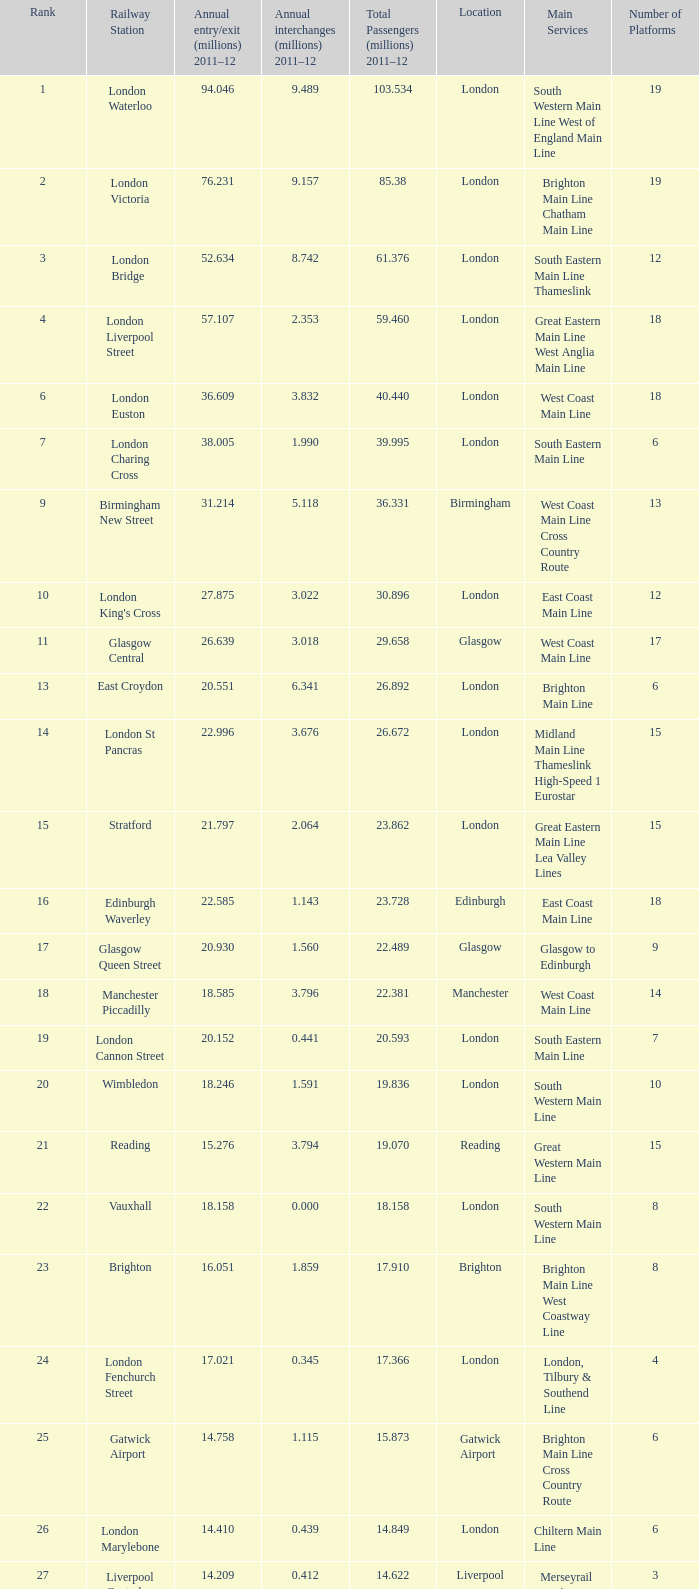Could you help me parse every detail presented in this table? {'header': ['Rank', 'Railway Station', 'Annual entry/exit (millions) 2011–12', 'Annual interchanges (millions) 2011–12', 'Total Passengers (millions) 2011–12', 'Location', 'Main Services', 'Number of Platforms'], 'rows': [['1', 'London Waterloo', '94.046', '9.489', '103.534', 'London', 'South Western Main Line West of England Main Line', '19'], ['2', 'London Victoria', '76.231', '9.157', '85.38', 'London', 'Brighton Main Line Chatham Main Line', '19'], ['3', 'London Bridge', '52.634', '8.742', '61.376', 'London', 'South Eastern Main Line Thameslink', '12'], ['4', 'London Liverpool Street', '57.107', '2.353', '59.460', 'London', 'Great Eastern Main Line West Anglia Main Line', '18'], ['6', 'London Euston', '36.609', '3.832', '40.440', 'London', 'West Coast Main Line', '18'], ['7', 'London Charing Cross', '38.005', '1.990', '39.995', 'London', 'South Eastern Main Line', '6'], ['9', 'Birmingham New Street', '31.214', '5.118', '36.331', 'Birmingham', 'West Coast Main Line Cross Country Route', '13'], ['10', "London King's Cross", '27.875', '3.022', '30.896', 'London', 'East Coast Main Line', '12'], ['11', 'Glasgow Central', '26.639', '3.018', '29.658', 'Glasgow', 'West Coast Main Line', '17'], ['13', 'East Croydon', '20.551', '6.341', '26.892', 'London', 'Brighton Main Line', '6'], ['14', 'London St Pancras', '22.996', '3.676', '26.672', 'London', 'Midland Main Line Thameslink High-Speed 1 Eurostar', '15'], ['15', 'Stratford', '21.797', '2.064', '23.862', 'London', 'Great Eastern Main Line Lea Valley Lines', '15'], ['16', 'Edinburgh Waverley', '22.585', '1.143', '23.728', 'Edinburgh', 'East Coast Main Line', '18'], ['17', 'Glasgow Queen Street', '20.930', '1.560', '22.489', 'Glasgow', 'Glasgow to Edinburgh', '9'], ['18', 'Manchester Piccadilly', '18.585', '3.796', '22.381', 'Manchester', 'West Coast Main Line', '14'], ['19', 'London Cannon Street', '20.152', '0.441', '20.593', 'London', 'South Eastern Main Line', '7'], ['20', 'Wimbledon', '18.246', '1.591', '19.836', 'London', 'South Western Main Line', '10'], ['21', 'Reading', '15.276', '3.794', '19.070', 'Reading', 'Great Western Main Line', '15'], ['22', 'Vauxhall', '18.158', '0.000', '18.158', 'London', 'South Western Main Line', '8'], ['23', 'Brighton', '16.051', '1.859', '17.910', 'Brighton', 'Brighton Main Line West Coastway Line', '8'], ['24', 'London Fenchurch Street', '17.021', '0.345', '17.366', 'London', 'London, Tilbury & Southend Line', '4'], ['25', 'Gatwick Airport', '14.758', '1.115', '15.873', 'Gatwick Airport', 'Brighton Main Line Cross Country Route', '6'], ['26', 'London Marylebone', '14.410', '0.439', '14.849', 'London', 'Chiltern Main Line', '6'], ['27', 'Liverpool Central', '14.209', '0.412', '14.622', 'Liverpool', 'Merseyrail services (Wirral and Northern lines)', '3'], ['28', 'Liverpool Lime Street', '13.835', '0.778', '14.613', 'Liverpool', 'West Coast Main Line Liverpool to Manchester Lines', '10'], ['29', 'London Blackfriars', '12.79', '1.059', '13.850', 'London', 'Thameslink', '4']]} 609 million? 3.832. 